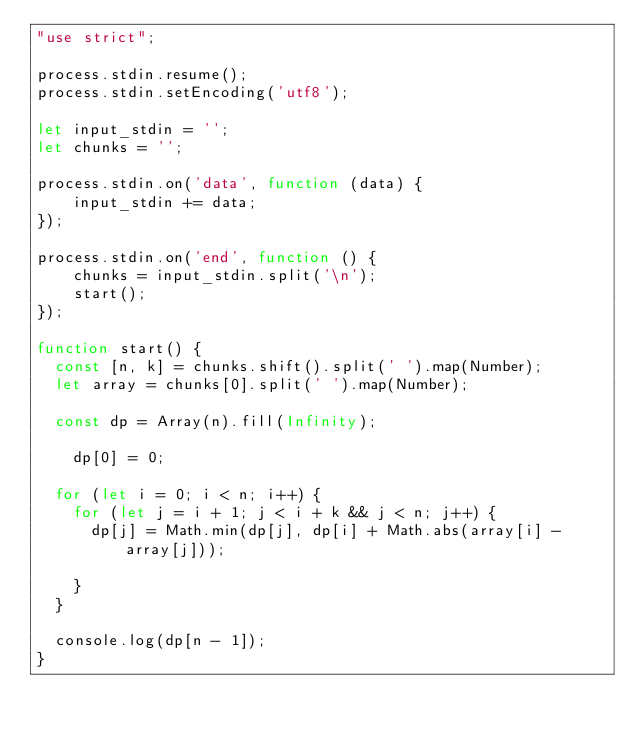<code> <loc_0><loc_0><loc_500><loc_500><_JavaScript_>"use strict";

process.stdin.resume();
process.stdin.setEncoding('utf8');

let input_stdin = '';
let chunks = '';

process.stdin.on('data', function (data) {
    input_stdin += data;
});

process.stdin.on('end', function () {
    chunks = input_stdin.split('\n');
    start();    
});

function start() {
	const [n, k] = chunks.shift().split(' ').map(Number);
	let array = chunks[0].split(' ').map(Number);

	const dp = Array(n).fill(Infinity);
  
  	dp[0] = 0;

	for (let i = 0; i < n; i++) {
		for (let j = i + 1; j < i + k && j < n; j++) {
			dp[j] = Math.min(dp[j], dp[i] + Math.abs(array[i] - array[j]));
          	
		}
	}

	console.log(dp[n - 1]);
}
</code> 